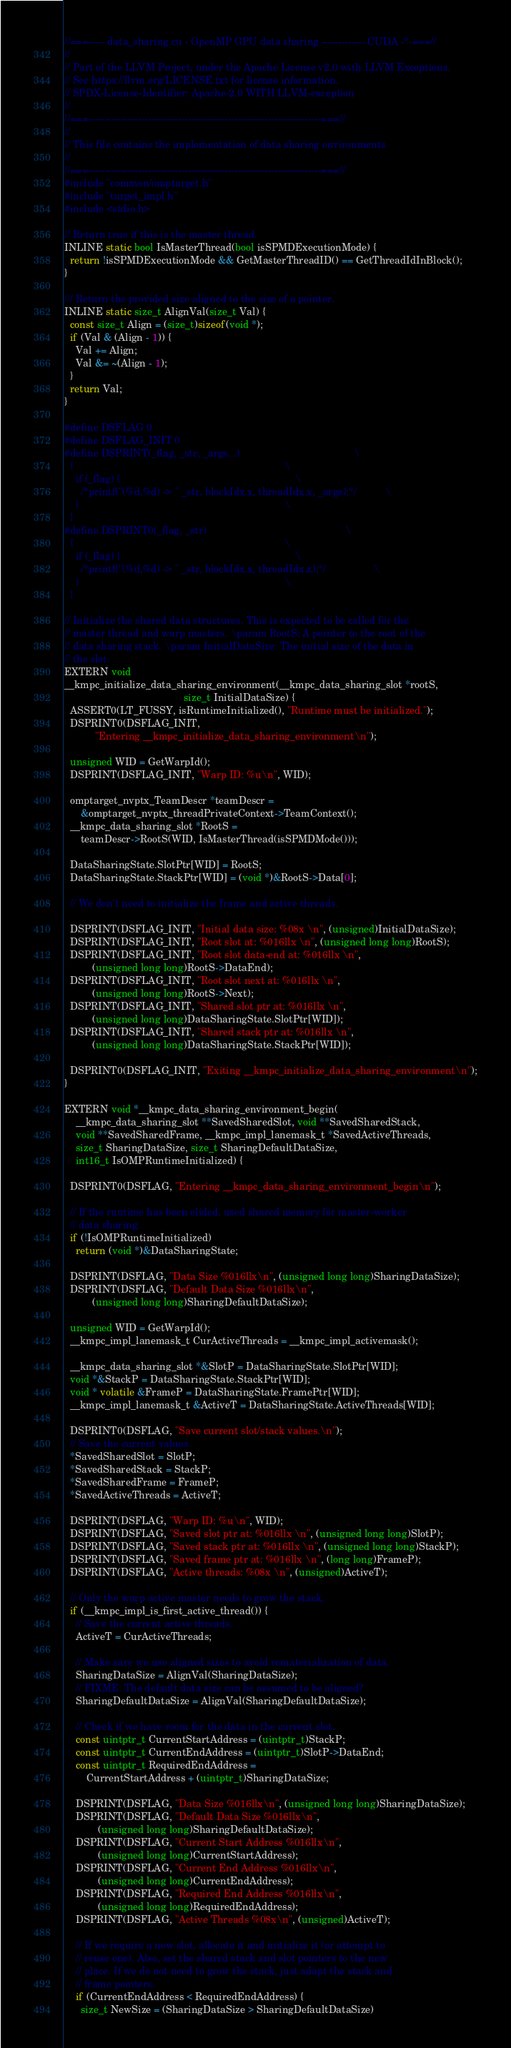<code> <loc_0><loc_0><loc_500><loc_500><_Cuda_>//===----- data_sharing.cu - OpenMP GPU data sharing ------------- CUDA -*-===//
//
// Part of the LLVM Project, under the Apache License v2.0 with LLVM Exceptions.
// See https://llvm.org/LICENSE.txt for license information.
// SPDX-License-Identifier: Apache-2.0 WITH LLVM-exception
//
//===----------------------------------------------------------------------===//
//
// This file contains the implementation of data sharing environments
//
//===----------------------------------------------------------------------===//
#include "common/omptarget.h"
#include "target_impl.h"
#include <stdio.h>

// Return true if this is the master thread.
INLINE static bool IsMasterThread(bool isSPMDExecutionMode) {
  return !isSPMDExecutionMode && GetMasterThreadID() == GetThreadIdInBlock();
}

/// Return the provided size aligned to the size of a pointer.
INLINE static size_t AlignVal(size_t Val) {
  const size_t Align = (size_t)sizeof(void *);
  if (Val & (Align - 1)) {
    Val += Align;
    Val &= ~(Align - 1);
  }
  return Val;
}

#define DSFLAG 0
#define DSFLAG_INIT 0
#define DSPRINT(_flag, _str, _args...)                                         \
  {                                                                            \
    if (_flag) {                                                               \
      /*printf("(%d,%d) -> " _str, blockIdx.x, threadIdx.x, _args);*/          \
    }                                                                          \
  }
#define DSPRINT0(_flag, _str)                                                  \
  {                                                                            \
    if (_flag) {                                                               \
      /*printf("(%d,%d) -> " _str, blockIdx.x, threadIdx.x);*/                 \
    }                                                                          \
  }

// Initialize the shared data structures. This is expected to be called for the
// master thread and warp masters. \param RootS: A pointer to the root of the
// data sharing stack. \param InitialDataSize: The initial size of the data in
// the slot.
EXTERN void
__kmpc_initialize_data_sharing_environment(__kmpc_data_sharing_slot *rootS,
                                           size_t InitialDataSize) {
  ASSERT0(LT_FUSSY, isRuntimeInitialized(), "Runtime must be initialized.");
  DSPRINT0(DSFLAG_INIT,
           "Entering __kmpc_initialize_data_sharing_environment\n");

  unsigned WID = GetWarpId();
  DSPRINT(DSFLAG_INIT, "Warp ID: %u\n", WID);

  omptarget_nvptx_TeamDescr *teamDescr =
      &omptarget_nvptx_threadPrivateContext->TeamContext();
  __kmpc_data_sharing_slot *RootS =
      teamDescr->RootS(WID, IsMasterThread(isSPMDMode()));

  DataSharingState.SlotPtr[WID] = RootS;
  DataSharingState.StackPtr[WID] = (void *)&RootS->Data[0];

  // We don't need to initialize the frame and active threads.

  DSPRINT(DSFLAG_INIT, "Initial data size: %08x \n", (unsigned)InitialDataSize);
  DSPRINT(DSFLAG_INIT, "Root slot at: %016llx \n", (unsigned long long)RootS);
  DSPRINT(DSFLAG_INIT, "Root slot data-end at: %016llx \n",
          (unsigned long long)RootS->DataEnd);
  DSPRINT(DSFLAG_INIT, "Root slot next at: %016llx \n",
          (unsigned long long)RootS->Next);
  DSPRINT(DSFLAG_INIT, "Shared slot ptr at: %016llx \n",
          (unsigned long long)DataSharingState.SlotPtr[WID]);
  DSPRINT(DSFLAG_INIT, "Shared stack ptr at: %016llx \n",
          (unsigned long long)DataSharingState.StackPtr[WID]);

  DSPRINT0(DSFLAG_INIT, "Exiting __kmpc_initialize_data_sharing_environment\n");
}

EXTERN void *__kmpc_data_sharing_environment_begin(
    __kmpc_data_sharing_slot **SavedSharedSlot, void **SavedSharedStack,
    void **SavedSharedFrame, __kmpc_impl_lanemask_t *SavedActiveThreads,
    size_t SharingDataSize, size_t SharingDefaultDataSize,
    int16_t IsOMPRuntimeInitialized) {

  DSPRINT0(DSFLAG, "Entering __kmpc_data_sharing_environment_begin\n");

  // If the runtime has been elided, used shared memory for master-worker
  // data sharing.
  if (!IsOMPRuntimeInitialized)
    return (void *)&DataSharingState;

  DSPRINT(DSFLAG, "Data Size %016llx\n", (unsigned long long)SharingDataSize);
  DSPRINT(DSFLAG, "Default Data Size %016llx\n",
          (unsigned long long)SharingDefaultDataSize);

  unsigned WID = GetWarpId();
  __kmpc_impl_lanemask_t CurActiveThreads = __kmpc_impl_activemask();

  __kmpc_data_sharing_slot *&SlotP = DataSharingState.SlotPtr[WID];
  void *&StackP = DataSharingState.StackPtr[WID];
  void * volatile &FrameP = DataSharingState.FramePtr[WID];
  __kmpc_impl_lanemask_t &ActiveT = DataSharingState.ActiveThreads[WID];

  DSPRINT0(DSFLAG, "Save current slot/stack values.\n");
  // Save the current values.
  *SavedSharedSlot = SlotP;
  *SavedSharedStack = StackP;
  *SavedSharedFrame = FrameP;
  *SavedActiveThreads = ActiveT;

  DSPRINT(DSFLAG, "Warp ID: %u\n", WID);
  DSPRINT(DSFLAG, "Saved slot ptr at: %016llx \n", (unsigned long long)SlotP);
  DSPRINT(DSFLAG, "Saved stack ptr at: %016llx \n", (unsigned long long)StackP);
  DSPRINT(DSFLAG, "Saved frame ptr at: %016llx \n", (long long)FrameP);
  DSPRINT(DSFLAG, "Active threads: %08x \n", (unsigned)ActiveT);

  // Only the warp active master needs to grow the stack.
  if (__kmpc_impl_is_first_active_thread()) {
    // Save the current active threads.
    ActiveT = CurActiveThreads;

    // Make sure we use aligned sizes to avoid rematerialization of data.
    SharingDataSize = AlignVal(SharingDataSize);
    // FIXME: The default data size can be assumed to be aligned?
    SharingDefaultDataSize = AlignVal(SharingDefaultDataSize);

    // Check if we have room for the data in the current slot.
    const uintptr_t CurrentStartAddress = (uintptr_t)StackP;
    const uintptr_t CurrentEndAddress = (uintptr_t)SlotP->DataEnd;
    const uintptr_t RequiredEndAddress =
        CurrentStartAddress + (uintptr_t)SharingDataSize;

    DSPRINT(DSFLAG, "Data Size %016llx\n", (unsigned long long)SharingDataSize);
    DSPRINT(DSFLAG, "Default Data Size %016llx\n",
            (unsigned long long)SharingDefaultDataSize);
    DSPRINT(DSFLAG, "Current Start Address %016llx\n",
            (unsigned long long)CurrentStartAddress);
    DSPRINT(DSFLAG, "Current End Address %016llx\n",
            (unsigned long long)CurrentEndAddress);
    DSPRINT(DSFLAG, "Required End Address %016llx\n",
            (unsigned long long)RequiredEndAddress);
    DSPRINT(DSFLAG, "Active Threads %08x\n", (unsigned)ActiveT);

    // If we require a new slot, allocate it and initialize it (or attempt to
    // reuse one). Also, set the shared stack and slot pointers to the new
    // place. If we do not need to grow the stack, just adapt the stack and
    // frame pointers.
    if (CurrentEndAddress < RequiredEndAddress) {
      size_t NewSize = (SharingDataSize > SharingDefaultDataSize)</code> 